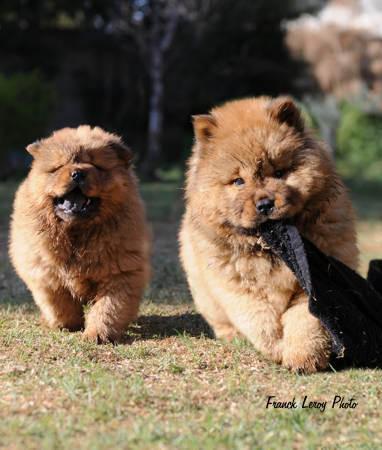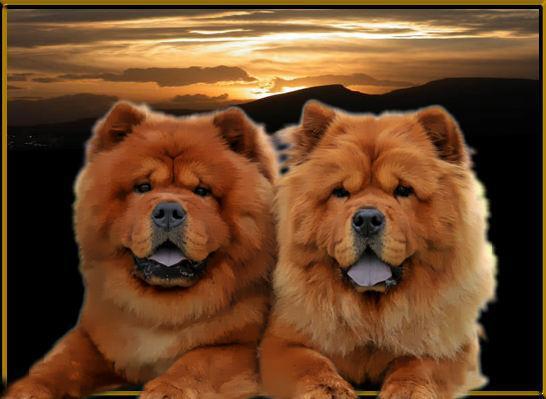The first image is the image on the left, the second image is the image on the right. Given the left and right images, does the statement "There are 4 chows in the image pair" hold true? Answer yes or no. Yes. The first image is the image on the left, the second image is the image on the right. Given the left and right images, does the statement "The right image contains exactly two chow dogs." hold true? Answer yes or no. Yes. 